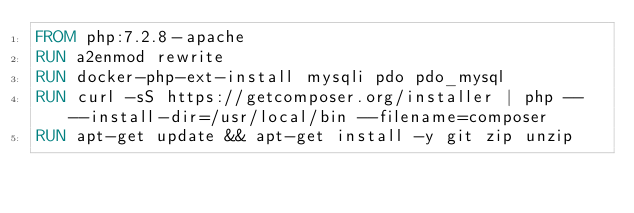<code> <loc_0><loc_0><loc_500><loc_500><_Dockerfile_>FROM php:7.2.8-apache
RUN a2enmod rewrite
RUN docker-php-ext-install mysqli pdo pdo_mysql
RUN curl -sS https://getcomposer.org/installer | php -- --install-dir=/usr/local/bin --filename=composer
RUN apt-get update && apt-get install -y git zip unzip</code> 